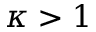Convert formula to latex. <formula><loc_0><loc_0><loc_500><loc_500>\kappa > 1</formula> 